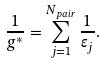<formula> <loc_0><loc_0><loc_500><loc_500>\frac { 1 } { g ^ { * } } = \sum _ { j = 1 } ^ { N _ { p a i r } } \frac { 1 } { \varepsilon _ { j } } .</formula> 